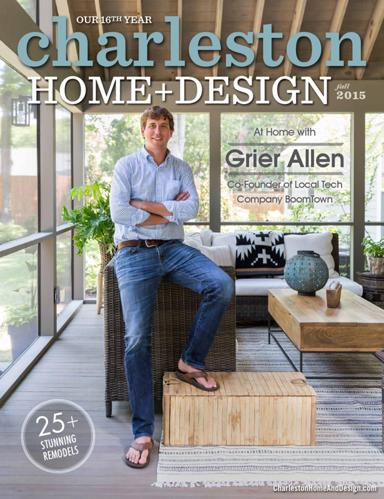What is being celebrated on the cover of Charleston Home Design?
 The 46th year of Charleston Home Design is being celebrated on the cover. Who is featured in the 2015 edition of Charleston Home Design? Grier Allen, the Co-Founder of the local tech company Boomtown, is featured in the 2015 edition of Charleston Home Design. What kind of remodeling projects are highlighted in the magazine? The magazine highlights 25 stunning remodels in its 2015 edition. 